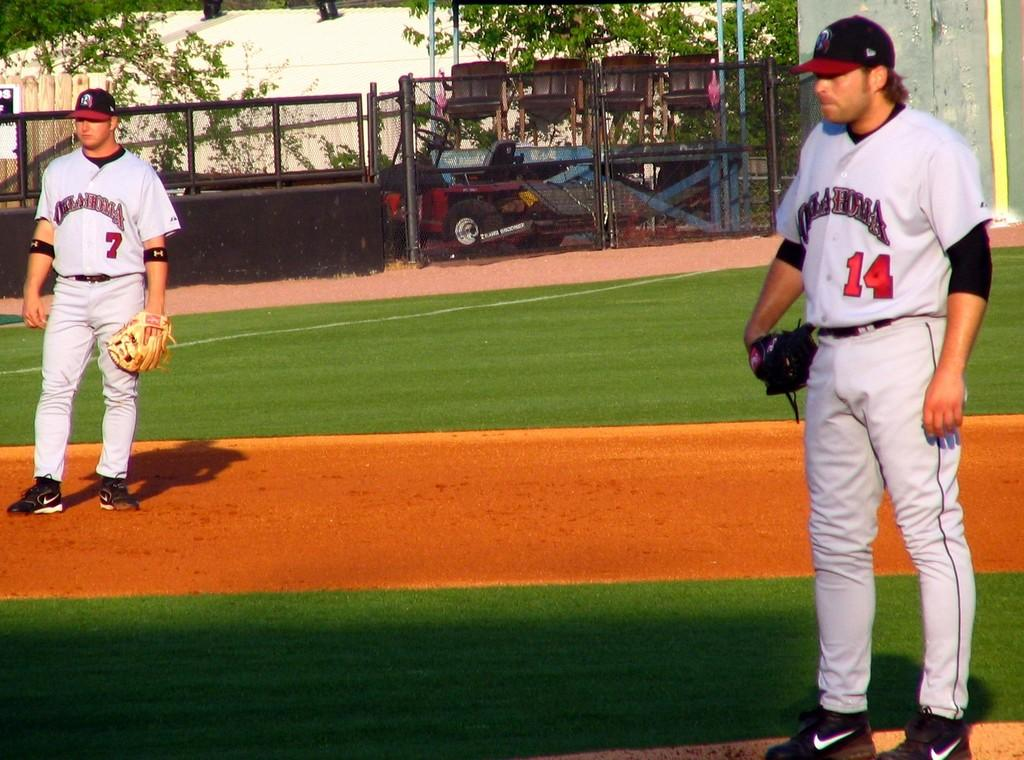<image>
Relay a brief, clear account of the picture shown. the number 14 is on the jersey of a person 